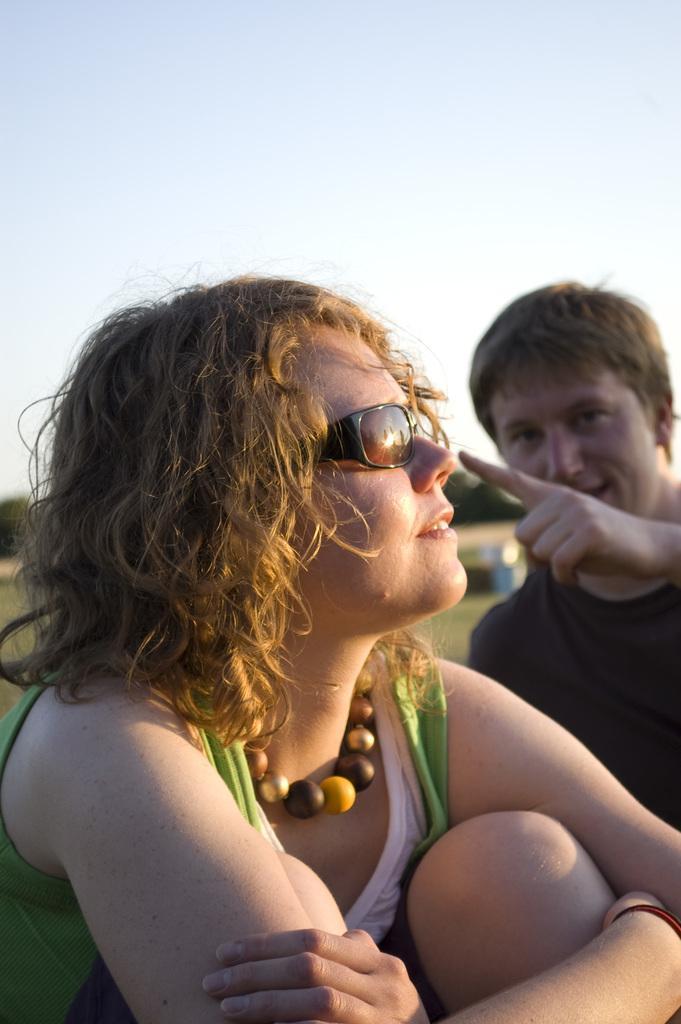Please provide a concise description of this image. In this image there are two people. There is grass. There are trees in the background. 